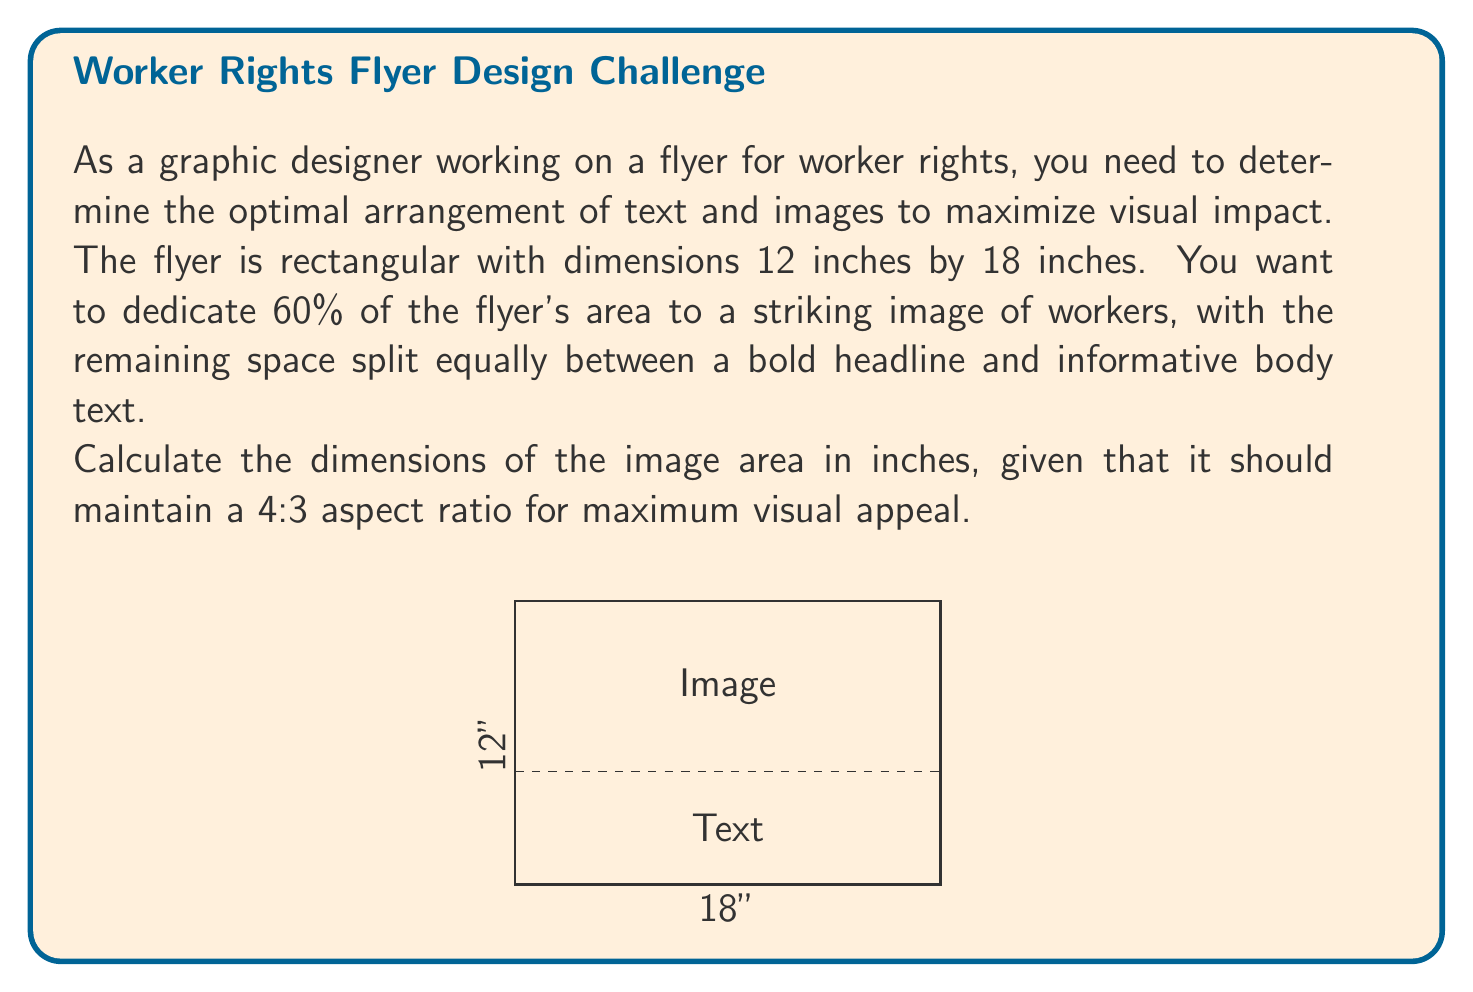Could you help me with this problem? Let's approach this step-by-step:

1) First, calculate the total area of the flyer:
   $A_{total} = 12 \text{ inches} \times 18 \text{ inches} = 216 \text{ sq inches}$

2) The image should occupy 60% of this area:
   $A_{image} = 0.60 \times 216 = 129.6 \text{ sq inches}$

3) We need to find dimensions for the image that:
   a) Have a 4:3 aspect ratio
   b) Have a total area of 129.6 sq inches

4) Let's say the width of the image is $4x$ and the height is $3x$. Then:
   $A_{image} = 4x \times 3x = 12x^2 = 129.6$

5) Solve for $x$:
   $x^2 = 129.6 \div 12 = 10.8$
   $x = \sqrt{10.8} = 3.286$

6) Therefore, the dimensions of the image are:
   Width = $4x = 4 \times 3.286 = 13.144$ inches
   Height = $3x = 3 \times 3.286 = 9.858$ inches

7) We can round these to two decimal places for practicality:
   Width ≈ 13.14 inches
   Height ≈ 9.86 inches
Answer: 13.14 inches × 9.86 inches 